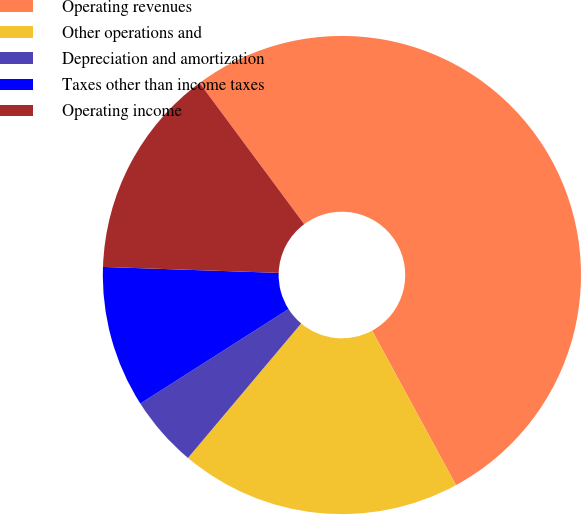Convert chart. <chart><loc_0><loc_0><loc_500><loc_500><pie_chart><fcel>Operating revenues<fcel>Other operations and<fcel>Depreciation and amortization<fcel>Taxes other than income taxes<fcel>Operating income<nl><fcel>52.23%<fcel>19.05%<fcel>4.83%<fcel>9.57%<fcel>14.31%<nl></chart> 